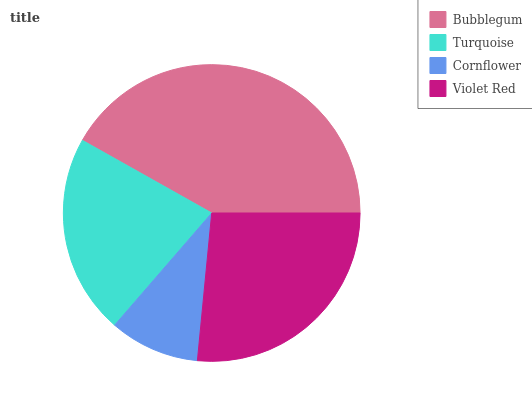Is Cornflower the minimum?
Answer yes or no. Yes. Is Bubblegum the maximum?
Answer yes or no. Yes. Is Turquoise the minimum?
Answer yes or no. No. Is Turquoise the maximum?
Answer yes or no. No. Is Bubblegum greater than Turquoise?
Answer yes or no. Yes. Is Turquoise less than Bubblegum?
Answer yes or no. Yes. Is Turquoise greater than Bubblegum?
Answer yes or no. No. Is Bubblegum less than Turquoise?
Answer yes or no. No. Is Violet Red the high median?
Answer yes or no. Yes. Is Turquoise the low median?
Answer yes or no. Yes. Is Bubblegum the high median?
Answer yes or no. No. Is Bubblegum the low median?
Answer yes or no. No. 